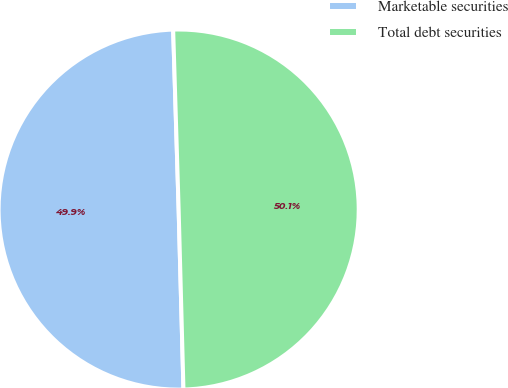<chart> <loc_0><loc_0><loc_500><loc_500><pie_chart><fcel>Marketable securities<fcel>Total debt securities<nl><fcel>49.94%<fcel>50.06%<nl></chart> 